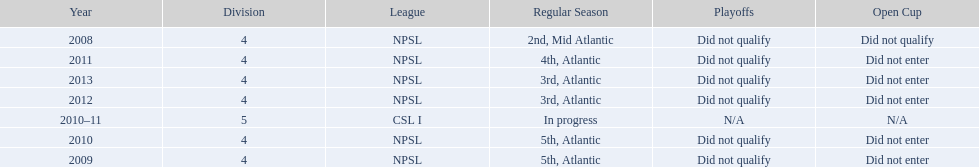What was the last year they came in 3rd place 2013. 